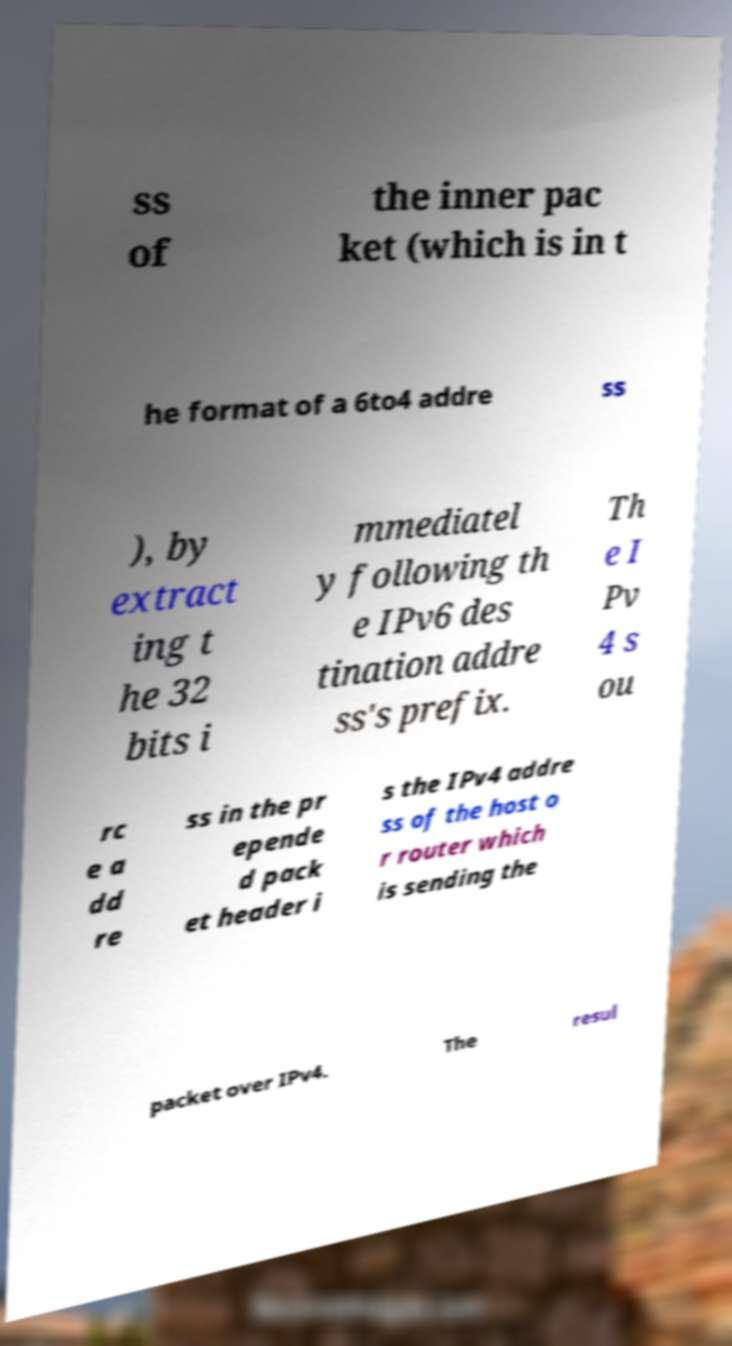For documentation purposes, I need the text within this image transcribed. Could you provide that? ss of the inner pac ket (which is in t he format of a 6to4 addre ss ), by extract ing t he 32 bits i mmediatel y following th e IPv6 des tination addre ss's prefix. Th e I Pv 4 s ou rc e a dd re ss in the pr epende d pack et header i s the IPv4 addre ss of the host o r router which is sending the packet over IPv4. The resul 